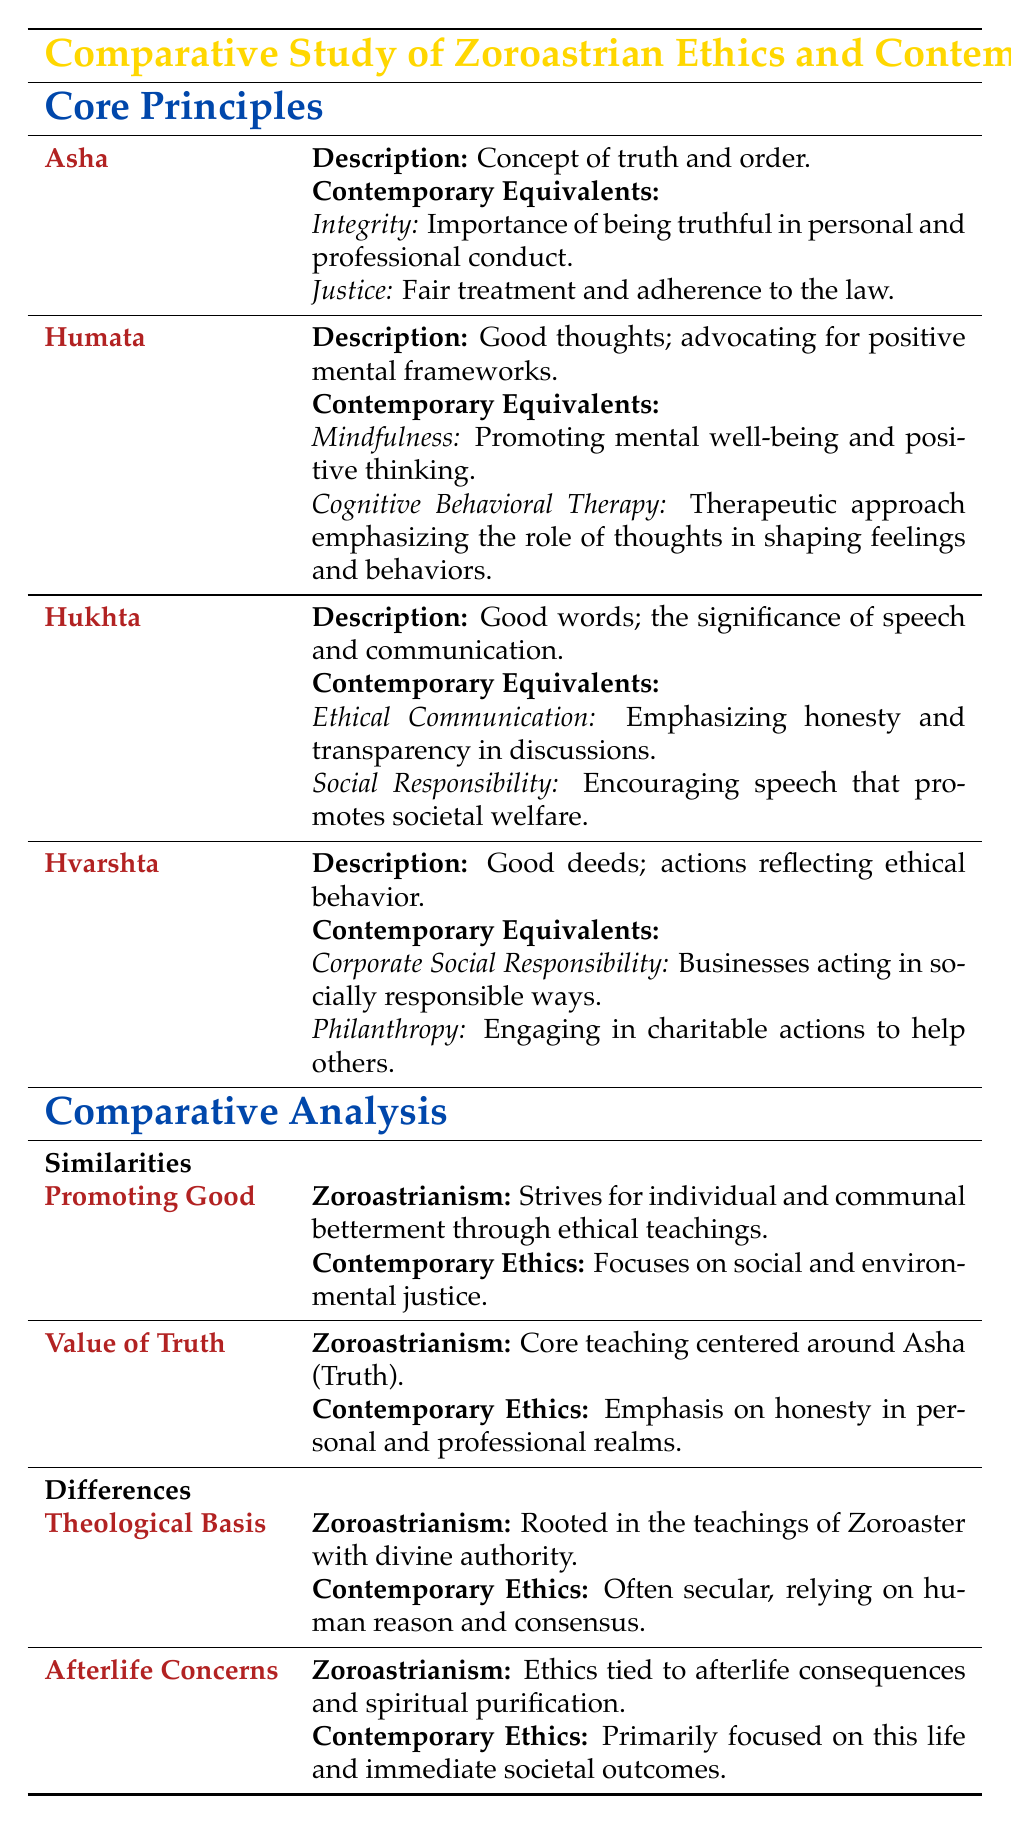What is the description of Asha? The table states that Asha represents the concept of truth and order. This is found directly under the section explaining the core principles of Zoroastrian ethics.
Answer: Concept of truth and order What are the contemporary equivalents of Hukhta? The contemporary equivalents of Hukhta as listed in the table include Ethical Communication, which emphasizes honesty and transparency in discussions, and Social Responsibility, which encourages speech that promotes societal welfare. This information is directly retrieved from the corresponding section of the table.
Answer: Ethical Communication and Social Responsibility Does Zoroastrianism emphasize the importance of mental well-being? According to the table, Zoroastrian ethics focus on Humata which advocates good thoughts and positive mental frameworks. However, the contemporary equivalents provided also imply a similar focus on mental well-being through mindfulness and cognitive behavioral therapy. Thus, the answer is yes, as the teachings relate to mental well-being.
Answer: Yes What is one significant similarity between Zoroastrian ethics and contemporary ethics? The table indicates that one significant similarity lies in the goal of promoting good, with Zoroastrianism striving for individual and communal betterment through ethical teachings, similar to contemporary ethics which focuses on social and environmental justice. This helps to illustrate a common goal shared by both sets of ethics.
Answer: Promoting good Which ethical principle is primarily focused on the significance of speech? The principle focusing on the significance of speech is Hukhta. The table describes it as good words and lists its contemporary equivalents under the corresponding section. This information is easily retrieved by looking at the core principles section.
Answer: Hukhta What are the ethical teachings related to afterlife consequences in Zoroastrianism? The table outlines that in Zoroastrianism, ethics are tied to afterlife consequences and spiritual purification. This is distinct from contemporary ethics, which are mainly focused on immediate societal outcomes. This detail is derived from the comparative analysis of differences.
Answer: Ethics tied to afterlife consequences and spiritual purification If Zoroastrian ethics are rooted in divine authority, are contemporary ethics also based on divine teachings? The table points out that Zoroastrianism's ethical teachings are rooted in Zoroaster's teachings with divine authority, whereas contemporary ethics are often secular, based on human reason and consensus. Therefore, the answer is no, as contemporary ethics do not share the same theological foundation.
Answer: No What contemporary equivalent corresponds to Hvarshta? The table states that the contemporary equivalents for Hvarshta, which emphasizes good deeds, include Corporate Social Responsibility and Philanthropy. This information can be found in the section specifically addressing Hvarshta.
Answer: Corporate Social Responsibility and Philanthropy 